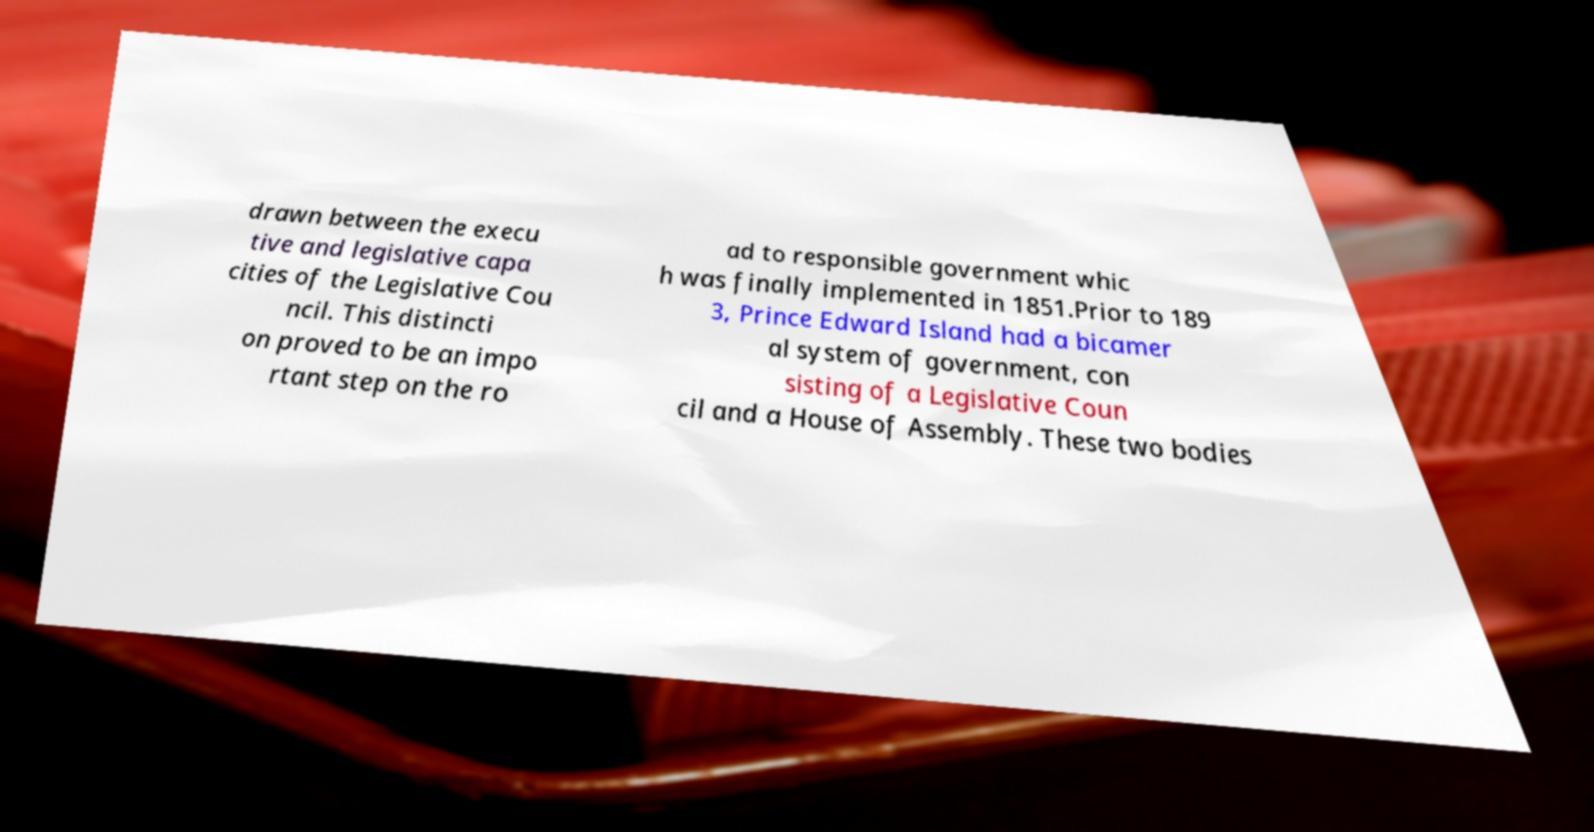Could you assist in decoding the text presented in this image and type it out clearly? drawn between the execu tive and legislative capa cities of the Legislative Cou ncil. This distincti on proved to be an impo rtant step on the ro ad to responsible government whic h was finally implemented in 1851.Prior to 189 3, Prince Edward Island had a bicamer al system of government, con sisting of a Legislative Coun cil and a House of Assembly. These two bodies 